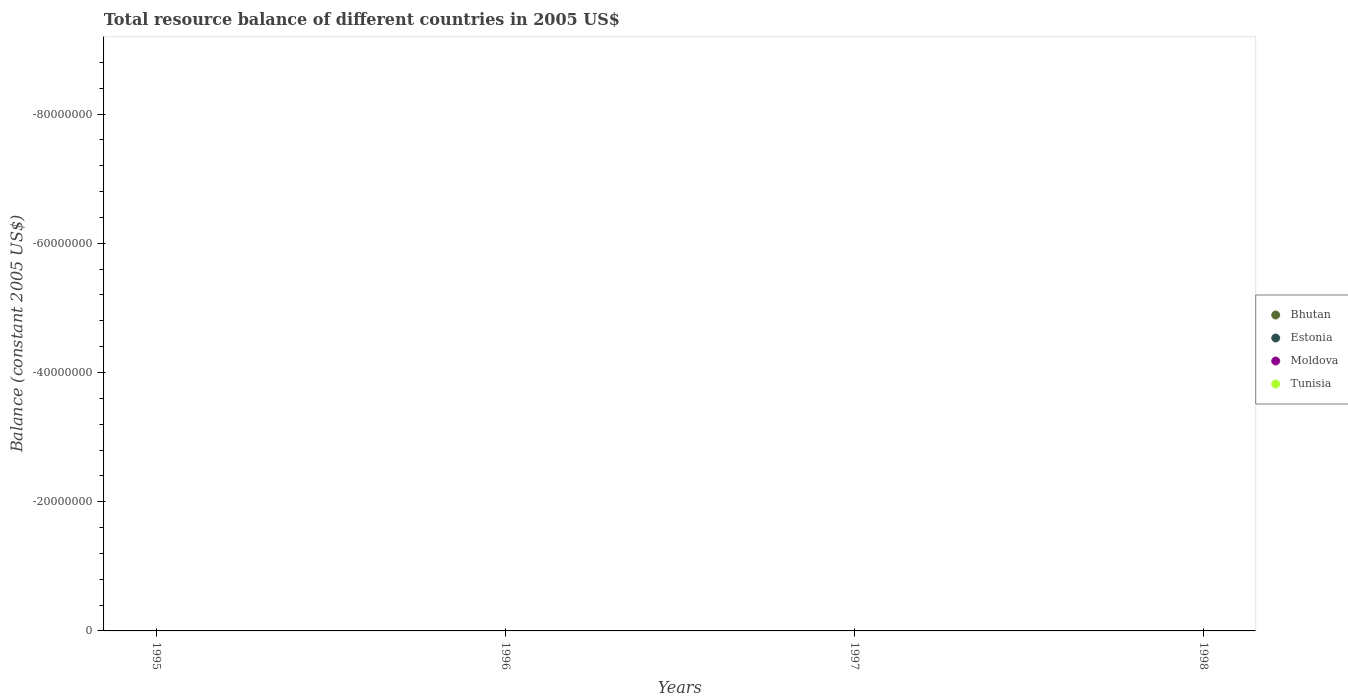How many different coloured dotlines are there?
Keep it short and to the point. 0. What is the total resource balance in Tunisia in 1998?
Offer a terse response. 0. Across all years, what is the minimum total resource balance in Moldova?
Keep it short and to the point. 0. What is the difference between the total resource balance in Estonia in 1997 and the total resource balance in Tunisia in 1996?
Provide a short and direct response. 0. In how many years, is the total resource balance in Bhutan greater than -12000000 US$?
Your answer should be compact. 0. Is it the case that in every year, the sum of the total resource balance in Moldova and total resource balance in Bhutan  is greater than the total resource balance in Estonia?
Your answer should be compact. No. Is the total resource balance in Tunisia strictly less than the total resource balance in Bhutan over the years?
Make the answer very short. No. What is the difference between two consecutive major ticks on the Y-axis?
Make the answer very short. 2.00e+07. Are the values on the major ticks of Y-axis written in scientific E-notation?
Offer a terse response. No. How many legend labels are there?
Keep it short and to the point. 4. What is the title of the graph?
Make the answer very short. Total resource balance of different countries in 2005 US$. What is the label or title of the X-axis?
Make the answer very short. Years. What is the label or title of the Y-axis?
Keep it short and to the point. Balance (constant 2005 US$). What is the Balance (constant 2005 US$) in Bhutan in 1995?
Give a very brief answer. 0. What is the Balance (constant 2005 US$) in Tunisia in 1995?
Offer a terse response. 0. What is the Balance (constant 2005 US$) of Bhutan in 1996?
Your response must be concise. 0. What is the Balance (constant 2005 US$) of Moldova in 1996?
Keep it short and to the point. 0. What is the Balance (constant 2005 US$) of Bhutan in 1997?
Give a very brief answer. 0. What is the Balance (constant 2005 US$) of Tunisia in 1997?
Give a very brief answer. 0. What is the Balance (constant 2005 US$) in Bhutan in 1998?
Make the answer very short. 0. What is the Balance (constant 2005 US$) in Estonia in 1998?
Provide a short and direct response. 0. What is the Balance (constant 2005 US$) of Moldova in 1998?
Provide a succinct answer. 0. What is the total Balance (constant 2005 US$) in Bhutan in the graph?
Your answer should be compact. 0. What is the total Balance (constant 2005 US$) of Estonia in the graph?
Provide a short and direct response. 0. What is the total Balance (constant 2005 US$) in Tunisia in the graph?
Keep it short and to the point. 0. What is the average Balance (constant 2005 US$) in Estonia per year?
Make the answer very short. 0. What is the average Balance (constant 2005 US$) of Tunisia per year?
Your response must be concise. 0. 